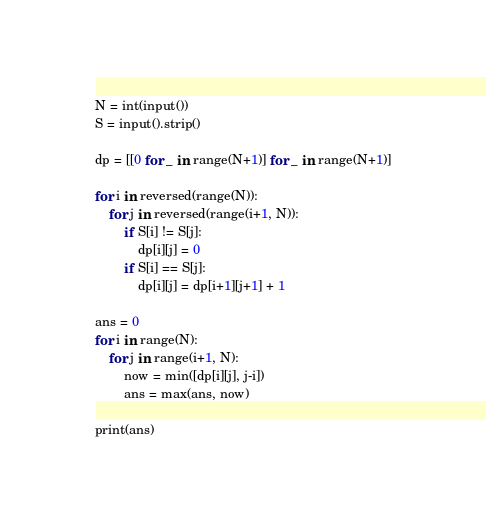Convert code to text. <code><loc_0><loc_0><loc_500><loc_500><_Python_>N = int(input())
S = input().strip()

dp = [[0 for _ in range(N+1)] for _ in range(N+1)]

for i in reversed(range(N)):
    for j in reversed(range(i+1, N)):
        if S[i] != S[j]:
            dp[i][j] = 0
        if S[i] == S[j]:
            dp[i][j] = dp[i+1][j+1] + 1

ans = 0
for i in range(N):
    for j in range(i+1, N):
        now = min([dp[i][j], j-i])
        ans = max(ans, now)

print(ans)
</code> 